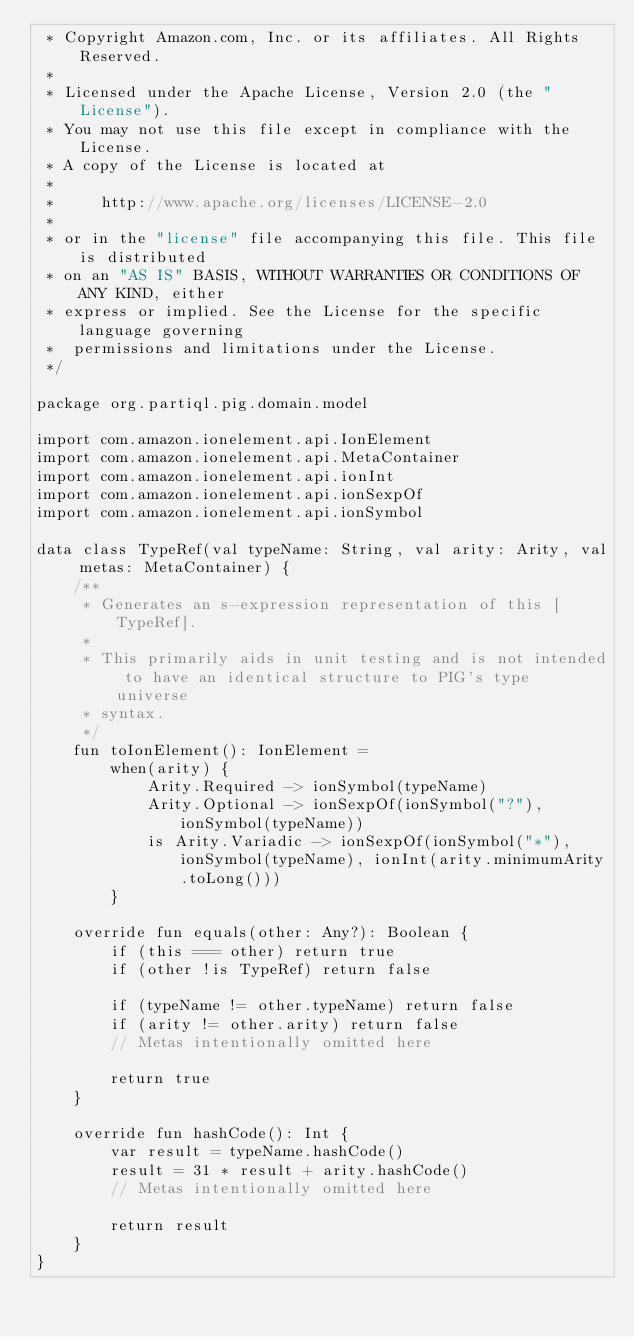Convert code to text. <code><loc_0><loc_0><loc_500><loc_500><_Kotlin_> * Copyright Amazon.com, Inc. or its affiliates. All Rights Reserved.
 *
 * Licensed under the Apache License, Version 2.0 (the "License").
 * You may not use this file except in compliance with the License.
 * A copy of the License is located at
 *
 *     http://www.apache.org/licenses/LICENSE-2.0
 *
 * or in the "license" file accompanying this file. This file is distributed
 * on an "AS IS" BASIS, WITHOUT WARRANTIES OR CONDITIONS OF ANY KIND, either
 * express or implied. See the License for the specific language governing
 *  permissions and limitations under the License.
 */

package org.partiql.pig.domain.model

import com.amazon.ionelement.api.IonElement
import com.amazon.ionelement.api.MetaContainer
import com.amazon.ionelement.api.ionInt
import com.amazon.ionelement.api.ionSexpOf
import com.amazon.ionelement.api.ionSymbol

data class TypeRef(val typeName: String, val arity: Arity, val metas: MetaContainer) {
    /**
     * Generates an s-expression representation of this [TypeRef].
     *
     * This primarily aids in unit testing and is not intended to have an identical structure to PIG's type universe
     * syntax.
     */
    fun toIonElement(): IonElement =
        when(arity) {
            Arity.Required -> ionSymbol(typeName)
            Arity.Optional -> ionSexpOf(ionSymbol("?"), ionSymbol(typeName))
            is Arity.Variadic -> ionSexpOf(ionSymbol("*"), ionSymbol(typeName), ionInt(arity.minimumArity.toLong()))
        }

    override fun equals(other: Any?): Boolean {
        if (this === other) return true
        if (other !is TypeRef) return false

        if (typeName != other.typeName) return false
        if (arity != other.arity) return false
        // Metas intentionally omitted here

        return true
    }

    override fun hashCode(): Int {
        var result = typeName.hashCode()
        result = 31 * result + arity.hashCode()
        // Metas intentionally omitted here

        return result
    }
}
</code> 